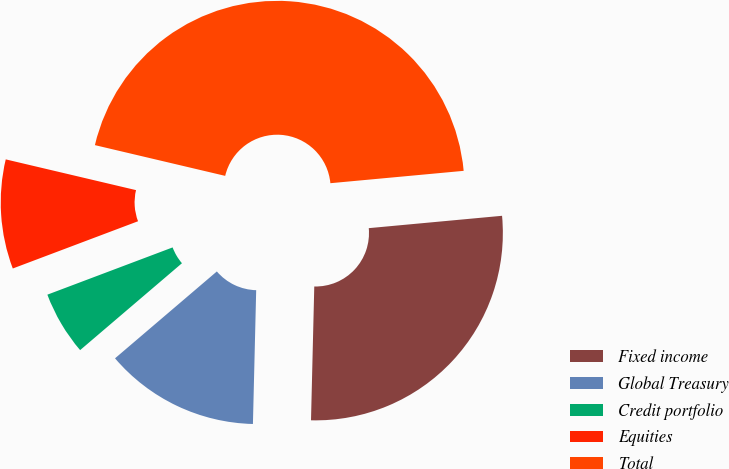<chart> <loc_0><loc_0><loc_500><loc_500><pie_chart><fcel>Fixed income<fcel>Global Treasury<fcel>Credit portfolio<fcel>Equities<fcel>Total<nl><fcel>26.86%<fcel>13.37%<fcel>5.5%<fcel>9.43%<fcel>44.84%<nl></chart> 